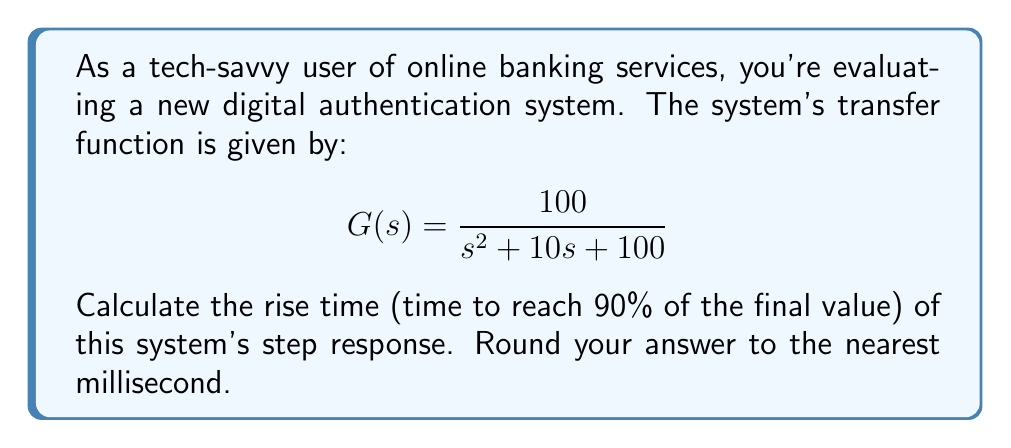Teach me how to tackle this problem. To solve this problem, we'll follow these steps:

1) First, we need to identify the system's natural frequency ($\omega_n$) and damping ratio ($\zeta$). From the given transfer function:

   $$G(s) = \frac{\omega_n^2}{s^2 + 2\zeta\omega_n s + \omega_n^2}$$

   We can see that $\omega_n^2 = 100$, so $\omega_n = 10$ rad/s.
   Also, $2\zeta\omega_n = 10$, so $\zeta = 0.5$.

2) For a second-order system with $0 < \zeta < 1$, we can use the approximate formula for rise time:

   $$t_r \approx \frac{1.8}{\omega_n}$$

3) Substituting our value for $\omega_n$:

   $$t_r \approx \frac{1.8}{10} = 0.18\text{ seconds}$$

4) Converting to milliseconds:

   $$t_r \approx 0.18 \times 1000 = 180\text{ milliseconds}$$

5) Rounding to the nearest millisecond:

   $$t_r \approx 180\text{ milliseconds}$$

This rise time represents how quickly the authentication system responds to input, which is crucial for a smooth user experience in online banking.
Answer: 180 milliseconds 